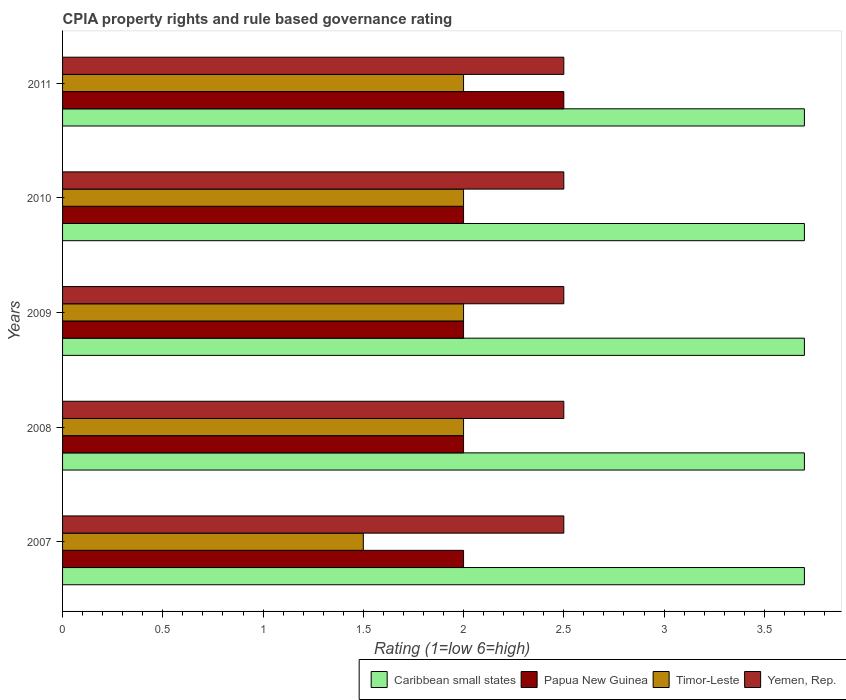How many different coloured bars are there?
Make the answer very short. 4. Are the number of bars per tick equal to the number of legend labels?
Provide a succinct answer. Yes. Are the number of bars on each tick of the Y-axis equal?
Give a very brief answer. Yes. How many bars are there on the 4th tick from the top?
Make the answer very short. 4. What is the label of the 4th group of bars from the top?
Give a very brief answer. 2008. In how many cases, is the number of bars for a given year not equal to the number of legend labels?
Provide a short and direct response. 0. Across all years, what is the maximum CPIA rating in Caribbean small states?
Ensure brevity in your answer.  3.7. In which year was the CPIA rating in Yemen, Rep. maximum?
Offer a very short reply. 2007. What is the total CPIA rating in Yemen, Rep. in the graph?
Offer a terse response. 12.5. What is the difference between the CPIA rating in Yemen, Rep. in 2011 and the CPIA rating in Papua New Guinea in 2007?
Keep it short and to the point. 0.5. What is the average CPIA rating in Caribbean small states per year?
Your answer should be very brief. 3.7. In the year 2008, what is the difference between the CPIA rating in Yemen, Rep. and CPIA rating in Timor-Leste?
Make the answer very short. 0.5. What is the ratio of the CPIA rating in Yemen, Rep. in 2008 to that in 2011?
Give a very brief answer. 1. Is the difference between the CPIA rating in Yemen, Rep. in 2007 and 2008 greater than the difference between the CPIA rating in Timor-Leste in 2007 and 2008?
Keep it short and to the point. Yes. Is it the case that in every year, the sum of the CPIA rating in Caribbean small states and CPIA rating in Yemen, Rep. is greater than the sum of CPIA rating in Papua New Guinea and CPIA rating in Timor-Leste?
Your response must be concise. Yes. What does the 2nd bar from the top in 2009 represents?
Offer a very short reply. Timor-Leste. What does the 1st bar from the bottom in 2010 represents?
Keep it short and to the point. Caribbean small states. How many bars are there?
Your answer should be very brief. 20. How many years are there in the graph?
Your response must be concise. 5. What is the difference between two consecutive major ticks on the X-axis?
Offer a terse response. 0.5. Where does the legend appear in the graph?
Offer a terse response. Bottom right. How many legend labels are there?
Your answer should be very brief. 4. How are the legend labels stacked?
Provide a short and direct response. Horizontal. What is the title of the graph?
Give a very brief answer. CPIA property rights and rule based governance rating. Does "Armenia" appear as one of the legend labels in the graph?
Offer a very short reply. No. What is the label or title of the Y-axis?
Make the answer very short. Years. What is the Rating (1=low 6=high) of Caribbean small states in 2007?
Offer a terse response. 3.7. What is the Rating (1=low 6=high) in Yemen, Rep. in 2007?
Offer a very short reply. 2.5. What is the Rating (1=low 6=high) of Papua New Guinea in 2008?
Your answer should be very brief. 2. What is the Rating (1=low 6=high) of Timor-Leste in 2008?
Ensure brevity in your answer.  2. What is the Rating (1=low 6=high) in Yemen, Rep. in 2008?
Provide a short and direct response. 2.5. What is the Rating (1=low 6=high) in Caribbean small states in 2009?
Provide a succinct answer. 3.7. What is the Rating (1=low 6=high) of Timor-Leste in 2009?
Keep it short and to the point. 2. What is the Rating (1=low 6=high) in Yemen, Rep. in 2009?
Offer a very short reply. 2.5. What is the Rating (1=low 6=high) of Timor-Leste in 2010?
Your answer should be very brief. 2. What is the Rating (1=low 6=high) in Yemen, Rep. in 2010?
Make the answer very short. 2.5. Across all years, what is the maximum Rating (1=low 6=high) in Caribbean small states?
Make the answer very short. 3.7. Across all years, what is the maximum Rating (1=low 6=high) in Papua New Guinea?
Your answer should be compact. 2.5. Across all years, what is the maximum Rating (1=low 6=high) of Timor-Leste?
Your answer should be very brief. 2. Across all years, what is the maximum Rating (1=low 6=high) of Yemen, Rep.?
Give a very brief answer. 2.5. Across all years, what is the minimum Rating (1=low 6=high) in Papua New Guinea?
Offer a terse response. 2. Across all years, what is the minimum Rating (1=low 6=high) in Yemen, Rep.?
Your response must be concise. 2.5. What is the total Rating (1=low 6=high) of Caribbean small states in the graph?
Provide a short and direct response. 18.5. What is the total Rating (1=low 6=high) of Papua New Guinea in the graph?
Give a very brief answer. 10.5. What is the difference between the Rating (1=low 6=high) in Caribbean small states in 2007 and that in 2009?
Offer a very short reply. 0. What is the difference between the Rating (1=low 6=high) in Timor-Leste in 2007 and that in 2009?
Your answer should be very brief. -0.5. What is the difference between the Rating (1=low 6=high) of Yemen, Rep. in 2007 and that in 2009?
Make the answer very short. 0. What is the difference between the Rating (1=low 6=high) of Caribbean small states in 2007 and that in 2010?
Keep it short and to the point. 0. What is the difference between the Rating (1=low 6=high) of Papua New Guinea in 2007 and that in 2010?
Make the answer very short. 0. What is the difference between the Rating (1=low 6=high) of Timor-Leste in 2007 and that in 2010?
Give a very brief answer. -0.5. What is the difference between the Rating (1=low 6=high) in Caribbean small states in 2008 and that in 2009?
Provide a succinct answer. 0. What is the difference between the Rating (1=low 6=high) of Timor-Leste in 2008 and that in 2009?
Your response must be concise. 0. What is the difference between the Rating (1=low 6=high) in Yemen, Rep. in 2008 and that in 2009?
Offer a terse response. 0. What is the difference between the Rating (1=low 6=high) in Caribbean small states in 2008 and that in 2010?
Make the answer very short. 0. What is the difference between the Rating (1=low 6=high) of Timor-Leste in 2008 and that in 2010?
Make the answer very short. 0. What is the difference between the Rating (1=low 6=high) in Yemen, Rep. in 2008 and that in 2010?
Your answer should be compact. 0. What is the difference between the Rating (1=low 6=high) in Caribbean small states in 2008 and that in 2011?
Make the answer very short. 0. What is the difference between the Rating (1=low 6=high) in Timor-Leste in 2008 and that in 2011?
Give a very brief answer. 0. What is the difference between the Rating (1=low 6=high) of Papua New Guinea in 2009 and that in 2010?
Ensure brevity in your answer.  0. What is the difference between the Rating (1=low 6=high) in Timor-Leste in 2009 and that in 2010?
Your answer should be very brief. 0. What is the difference between the Rating (1=low 6=high) of Timor-Leste in 2009 and that in 2011?
Your answer should be compact. 0. What is the difference between the Rating (1=low 6=high) of Yemen, Rep. in 2009 and that in 2011?
Offer a very short reply. 0. What is the difference between the Rating (1=low 6=high) in Papua New Guinea in 2010 and that in 2011?
Keep it short and to the point. -0.5. What is the difference between the Rating (1=low 6=high) in Timor-Leste in 2010 and that in 2011?
Provide a short and direct response. 0. What is the difference between the Rating (1=low 6=high) in Caribbean small states in 2007 and the Rating (1=low 6=high) in Papua New Guinea in 2008?
Your answer should be very brief. 1.7. What is the difference between the Rating (1=low 6=high) in Timor-Leste in 2007 and the Rating (1=low 6=high) in Yemen, Rep. in 2008?
Ensure brevity in your answer.  -1. What is the difference between the Rating (1=low 6=high) in Caribbean small states in 2007 and the Rating (1=low 6=high) in Papua New Guinea in 2009?
Provide a succinct answer. 1.7. What is the difference between the Rating (1=low 6=high) of Caribbean small states in 2007 and the Rating (1=low 6=high) of Timor-Leste in 2009?
Offer a very short reply. 1.7. What is the difference between the Rating (1=low 6=high) of Caribbean small states in 2007 and the Rating (1=low 6=high) of Yemen, Rep. in 2009?
Your answer should be compact. 1.2. What is the difference between the Rating (1=low 6=high) of Papua New Guinea in 2007 and the Rating (1=low 6=high) of Yemen, Rep. in 2009?
Give a very brief answer. -0.5. What is the difference between the Rating (1=low 6=high) of Timor-Leste in 2007 and the Rating (1=low 6=high) of Yemen, Rep. in 2009?
Ensure brevity in your answer.  -1. What is the difference between the Rating (1=low 6=high) in Caribbean small states in 2007 and the Rating (1=low 6=high) in Papua New Guinea in 2010?
Ensure brevity in your answer.  1.7. What is the difference between the Rating (1=low 6=high) in Caribbean small states in 2007 and the Rating (1=low 6=high) in Yemen, Rep. in 2010?
Give a very brief answer. 1.2. What is the difference between the Rating (1=low 6=high) in Papua New Guinea in 2007 and the Rating (1=low 6=high) in Yemen, Rep. in 2010?
Your response must be concise. -0.5. What is the difference between the Rating (1=low 6=high) in Caribbean small states in 2007 and the Rating (1=low 6=high) in Yemen, Rep. in 2011?
Your answer should be very brief. 1.2. What is the difference between the Rating (1=low 6=high) of Papua New Guinea in 2007 and the Rating (1=low 6=high) of Timor-Leste in 2011?
Keep it short and to the point. 0. What is the difference between the Rating (1=low 6=high) in Papua New Guinea in 2007 and the Rating (1=low 6=high) in Yemen, Rep. in 2011?
Offer a very short reply. -0.5. What is the difference between the Rating (1=low 6=high) of Caribbean small states in 2008 and the Rating (1=low 6=high) of Yemen, Rep. in 2009?
Offer a very short reply. 1.2. What is the difference between the Rating (1=low 6=high) of Papua New Guinea in 2008 and the Rating (1=low 6=high) of Timor-Leste in 2009?
Provide a short and direct response. 0. What is the difference between the Rating (1=low 6=high) in Timor-Leste in 2008 and the Rating (1=low 6=high) in Yemen, Rep. in 2009?
Give a very brief answer. -0.5. What is the difference between the Rating (1=low 6=high) in Caribbean small states in 2008 and the Rating (1=low 6=high) in Papua New Guinea in 2010?
Offer a terse response. 1.7. What is the difference between the Rating (1=low 6=high) in Caribbean small states in 2008 and the Rating (1=low 6=high) in Timor-Leste in 2010?
Give a very brief answer. 1.7. What is the difference between the Rating (1=low 6=high) of Papua New Guinea in 2008 and the Rating (1=low 6=high) of Timor-Leste in 2010?
Your response must be concise. 0. What is the difference between the Rating (1=low 6=high) in Timor-Leste in 2008 and the Rating (1=low 6=high) in Yemen, Rep. in 2010?
Your answer should be compact. -0.5. What is the difference between the Rating (1=low 6=high) in Caribbean small states in 2008 and the Rating (1=low 6=high) in Papua New Guinea in 2011?
Give a very brief answer. 1.2. What is the difference between the Rating (1=low 6=high) of Timor-Leste in 2008 and the Rating (1=low 6=high) of Yemen, Rep. in 2011?
Keep it short and to the point. -0.5. What is the difference between the Rating (1=low 6=high) of Caribbean small states in 2009 and the Rating (1=low 6=high) of Timor-Leste in 2010?
Provide a short and direct response. 1.7. What is the difference between the Rating (1=low 6=high) of Caribbean small states in 2009 and the Rating (1=low 6=high) of Yemen, Rep. in 2011?
Provide a succinct answer. 1.2. What is the difference between the Rating (1=low 6=high) in Papua New Guinea in 2009 and the Rating (1=low 6=high) in Timor-Leste in 2011?
Provide a short and direct response. 0. What is the difference between the Rating (1=low 6=high) of Caribbean small states in 2010 and the Rating (1=low 6=high) of Yemen, Rep. in 2011?
Make the answer very short. 1.2. What is the difference between the Rating (1=low 6=high) of Papua New Guinea in 2010 and the Rating (1=low 6=high) of Yemen, Rep. in 2011?
Keep it short and to the point. -0.5. What is the difference between the Rating (1=low 6=high) of Timor-Leste in 2010 and the Rating (1=low 6=high) of Yemen, Rep. in 2011?
Give a very brief answer. -0.5. What is the average Rating (1=low 6=high) of Timor-Leste per year?
Ensure brevity in your answer.  1.9. In the year 2007, what is the difference between the Rating (1=low 6=high) of Caribbean small states and Rating (1=low 6=high) of Papua New Guinea?
Ensure brevity in your answer.  1.7. In the year 2007, what is the difference between the Rating (1=low 6=high) in Caribbean small states and Rating (1=low 6=high) in Yemen, Rep.?
Offer a terse response. 1.2. In the year 2007, what is the difference between the Rating (1=low 6=high) of Papua New Guinea and Rating (1=low 6=high) of Yemen, Rep.?
Your answer should be very brief. -0.5. In the year 2008, what is the difference between the Rating (1=low 6=high) of Caribbean small states and Rating (1=low 6=high) of Yemen, Rep.?
Your answer should be compact. 1.2. In the year 2008, what is the difference between the Rating (1=low 6=high) of Papua New Guinea and Rating (1=low 6=high) of Yemen, Rep.?
Your response must be concise. -0.5. In the year 2009, what is the difference between the Rating (1=low 6=high) in Caribbean small states and Rating (1=low 6=high) in Papua New Guinea?
Make the answer very short. 1.7. In the year 2009, what is the difference between the Rating (1=low 6=high) in Caribbean small states and Rating (1=low 6=high) in Timor-Leste?
Your response must be concise. 1.7. In the year 2009, what is the difference between the Rating (1=low 6=high) of Papua New Guinea and Rating (1=low 6=high) of Timor-Leste?
Your response must be concise. 0. In the year 2010, what is the difference between the Rating (1=low 6=high) in Caribbean small states and Rating (1=low 6=high) in Papua New Guinea?
Give a very brief answer. 1.7. In the year 2010, what is the difference between the Rating (1=low 6=high) in Caribbean small states and Rating (1=low 6=high) in Yemen, Rep.?
Provide a short and direct response. 1.2. In the year 2010, what is the difference between the Rating (1=low 6=high) in Papua New Guinea and Rating (1=low 6=high) in Timor-Leste?
Your response must be concise. 0. In the year 2011, what is the difference between the Rating (1=low 6=high) in Caribbean small states and Rating (1=low 6=high) in Papua New Guinea?
Make the answer very short. 1.2. In the year 2011, what is the difference between the Rating (1=low 6=high) of Caribbean small states and Rating (1=low 6=high) of Timor-Leste?
Your answer should be very brief. 1.7. In the year 2011, what is the difference between the Rating (1=low 6=high) of Caribbean small states and Rating (1=low 6=high) of Yemen, Rep.?
Ensure brevity in your answer.  1.2. In the year 2011, what is the difference between the Rating (1=low 6=high) in Timor-Leste and Rating (1=low 6=high) in Yemen, Rep.?
Offer a very short reply. -0.5. What is the ratio of the Rating (1=low 6=high) in Papua New Guinea in 2007 to that in 2008?
Provide a short and direct response. 1. What is the ratio of the Rating (1=low 6=high) in Caribbean small states in 2007 to that in 2009?
Your response must be concise. 1. What is the ratio of the Rating (1=low 6=high) in Papua New Guinea in 2007 to that in 2009?
Make the answer very short. 1. What is the ratio of the Rating (1=low 6=high) of Yemen, Rep. in 2007 to that in 2009?
Offer a very short reply. 1. What is the ratio of the Rating (1=low 6=high) in Caribbean small states in 2007 to that in 2010?
Your response must be concise. 1. What is the ratio of the Rating (1=low 6=high) of Papua New Guinea in 2007 to that in 2010?
Keep it short and to the point. 1. What is the ratio of the Rating (1=low 6=high) of Timor-Leste in 2007 to that in 2011?
Give a very brief answer. 0.75. What is the ratio of the Rating (1=low 6=high) of Yemen, Rep. in 2007 to that in 2011?
Keep it short and to the point. 1. What is the ratio of the Rating (1=low 6=high) in Caribbean small states in 2008 to that in 2009?
Your response must be concise. 1. What is the ratio of the Rating (1=low 6=high) of Caribbean small states in 2008 to that in 2010?
Give a very brief answer. 1. What is the ratio of the Rating (1=low 6=high) of Papua New Guinea in 2008 to that in 2011?
Your response must be concise. 0.8. What is the ratio of the Rating (1=low 6=high) of Caribbean small states in 2009 to that in 2010?
Offer a very short reply. 1. What is the ratio of the Rating (1=low 6=high) in Yemen, Rep. in 2009 to that in 2010?
Make the answer very short. 1. What is the ratio of the Rating (1=low 6=high) of Papua New Guinea in 2009 to that in 2011?
Make the answer very short. 0.8. What is the ratio of the Rating (1=low 6=high) of Yemen, Rep. in 2009 to that in 2011?
Give a very brief answer. 1. What is the ratio of the Rating (1=low 6=high) of Papua New Guinea in 2010 to that in 2011?
Keep it short and to the point. 0.8. What is the difference between the highest and the lowest Rating (1=low 6=high) in Yemen, Rep.?
Make the answer very short. 0. 